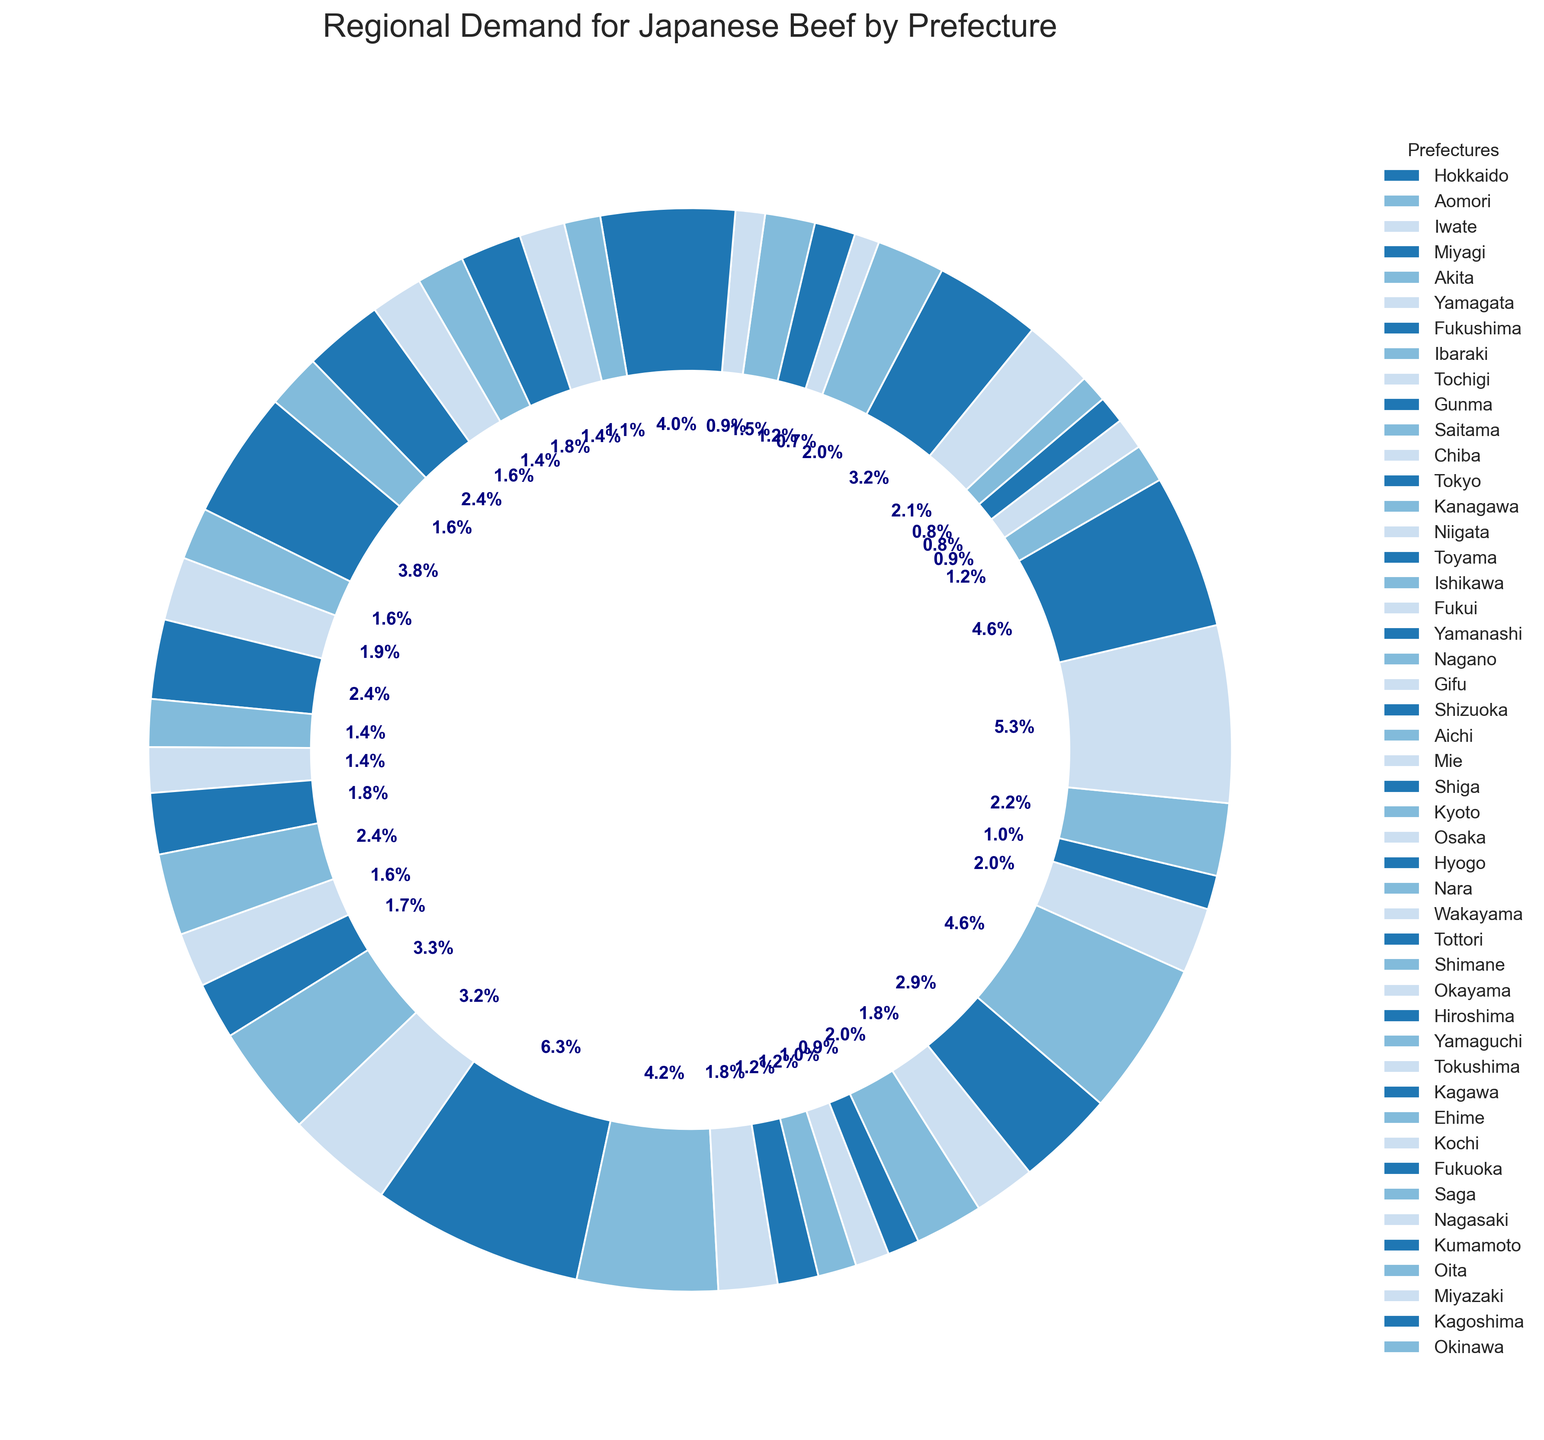What percentage of the total demand is accounted for by Tokyo? Find Tokyo's wedge in the chart and read the percentage label assigned.
Answer: 8.2% Which prefecture has the second-highest demand for Japanese Beef? Look at the sizes of the wedges and find the one that is second largest after Tokyo. Identify and match it to the prefecture from the legend.
Answer: Osaka How does the demand in Hokkaido compare to that in Fukuoka? Identify and compare the sizes of Hokkaido and Fukuoka's wedges in the chart. Determine which wedge is larger.
Answer: Hokkaido is higher than Fukuoka What’s the combined demand percentage for Aichi and Hyogo? Locate Aichi and Hyogo in the legend, note their percentages in the chart, and sum them up, e.g., Aichi: 6.0%, and Hyogo: 6.0%.
Answer: 12% Which prefecture in the central region (Nagano, Gifu, and Shizuoka) has the highest demand? Identify and compare the wedges representing Nagano, Gifu, and Shizuoka. Find the one with the largest wedge.
Answer: Shizuoka What is the demand difference in metric tons between Tokyo and Kanagawa? Identify their demands (Tokyo: 9300, Kanagawa: 6200) and subtract Kanagawa’s demand from Tokyo’s.
Answer: 3100 metric tons What's the smallest demand for Japanese Beef by any prefecture, and which prefecture does it belong to? Identify the wedge with the smallest percentage label and match it to the prefecture from the legend.
Answer: Tokushima If we combine the demand for Hokkaido, Aomori, and Iwate, what percentage of the total does it represent? Find the wedges for Hokkaido, Aomori, and Iwate and sum up their percentages.
Answer: 13.5% Which regions have very close demand percentages (difference within 0.1%)? Compare the percentages of neighboring wedges to find pairs with a very similar percentage label.
Answer: Aomori and Oita How does the demand in Tokyo compare to the cumulative demand of all Tohoku region prefectures (Aomori, Iwate, Miyagi, Akita, Yamagata, Fukushima)? Sum up percentages of Tohoku region prefectures and compare with Tokyo's percentage label. To summarize: Aomori: 2.0%, Iwate: 2.4%, Miyagi: 3.0%, Akita: 1.8%, Yamagata: 1.6%, Fukushima: 2.3% making total 13.1%. Tokyo is 8.2%. Thus, Tokyo's demand percentage is less than cumulative Tohoku region.
Answer: Tokyo is less 